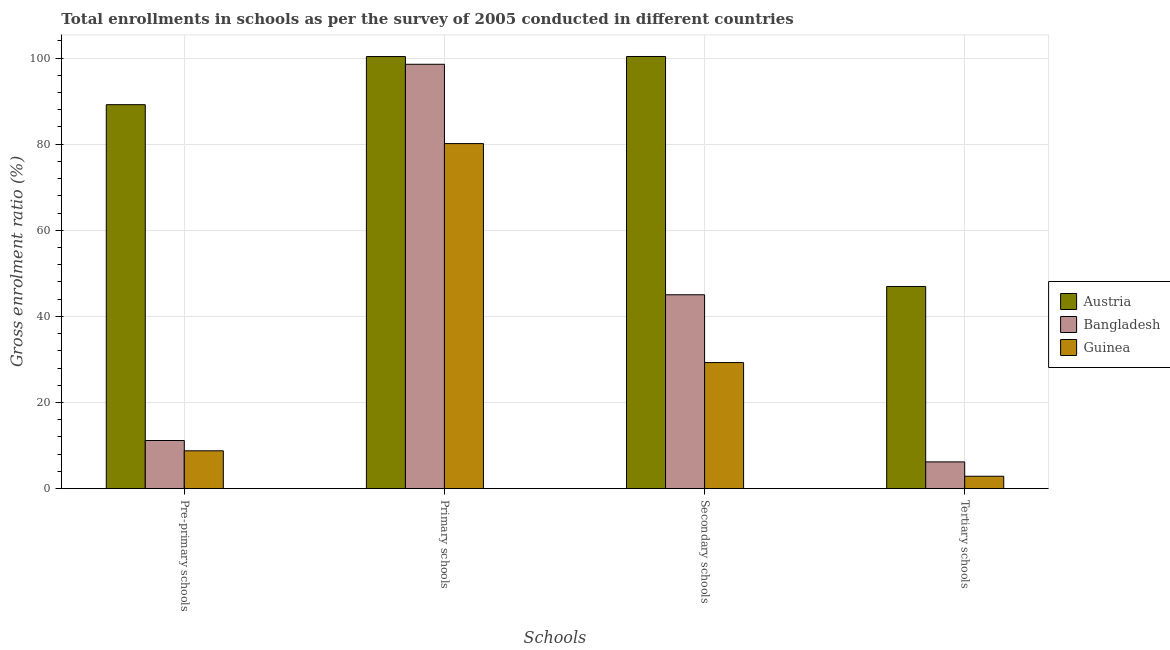Are the number of bars per tick equal to the number of legend labels?
Ensure brevity in your answer.  Yes. What is the label of the 3rd group of bars from the left?
Make the answer very short. Secondary schools. What is the gross enrolment ratio in tertiary schools in Bangladesh?
Give a very brief answer. 6.22. Across all countries, what is the maximum gross enrolment ratio in secondary schools?
Your answer should be very brief. 100.35. Across all countries, what is the minimum gross enrolment ratio in pre-primary schools?
Your answer should be compact. 8.79. In which country was the gross enrolment ratio in tertiary schools maximum?
Ensure brevity in your answer.  Austria. In which country was the gross enrolment ratio in primary schools minimum?
Offer a very short reply. Guinea. What is the total gross enrolment ratio in pre-primary schools in the graph?
Provide a short and direct response. 109.14. What is the difference between the gross enrolment ratio in secondary schools in Guinea and that in Austria?
Provide a succinct answer. -71.07. What is the difference between the gross enrolment ratio in primary schools in Bangladesh and the gross enrolment ratio in pre-primary schools in Austria?
Offer a terse response. 9.38. What is the average gross enrolment ratio in secondary schools per country?
Give a very brief answer. 58.22. What is the difference between the gross enrolment ratio in pre-primary schools and gross enrolment ratio in secondary schools in Guinea?
Keep it short and to the point. -20.49. What is the ratio of the gross enrolment ratio in primary schools in Austria to that in Guinea?
Offer a very short reply. 1.25. What is the difference between the highest and the second highest gross enrolment ratio in tertiary schools?
Keep it short and to the point. 40.73. What is the difference between the highest and the lowest gross enrolment ratio in secondary schools?
Provide a succinct answer. 71.07. What does the 3rd bar from the left in Primary schools represents?
Provide a short and direct response. Guinea. What does the 1st bar from the right in Tertiary schools represents?
Your answer should be very brief. Guinea. How many bars are there?
Ensure brevity in your answer.  12. How many countries are there in the graph?
Keep it short and to the point. 3. What is the difference between two consecutive major ticks on the Y-axis?
Give a very brief answer. 20. Are the values on the major ticks of Y-axis written in scientific E-notation?
Keep it short and to the point. No. Does the graph contain any zero values?
Provide a short and direct response. No. How many legend labels are there?
Ensure brevity in your answer.  3. How are the legend labels stacked?
Offer a terse response. Vertical. What is the title of the graph?
Make the answer very short. Total enrollments in schools as per the survey of 2005 conducted in different countries. What is the label or title of the X-axis?
Provide a succinct answer. Schools. What is the label or title of the Y-axis?
Provide a short and direct response. Gross enrolment ratio (%). What is the Gross enrolment ratio (%) of Austria in Pre-primary schools?
Your answer should be very brief. 89.16. What is the Gross enrolment ratio (%) in Bangladesh in Pre-primary schools?
Provide a succinct answer. 11.18. What is the Gross enrolment ratio (%) of Guinea in Pre-primary schools?
Your answer should be compact. 8.79. What is the Gross enrolment ratio (%) of Austria in Primary schools?
Keep it short and to the point. 100.33. What is the Gross enrolment ratio (%) in Bangladesh in Primary schools?
Offer a very short reply. 98.54. What is the Gross enrolment ratio (%) of Guinea in Primary schools?
Provide a short and direct response. 80.13. What is the Gross enrolment ratio (%) of Austria in Secondary schools?
Provide a short and direct response. 100.35. What is the Gross enrolment ratio (%) in Bangladesh in Secondary schools?
Provide a short and direct response. 45.02. What is the Gross enrolment ratio (%) of Guinea in Secondary schools?
Your response must be concise. 29.28. What is the Gross enrolment ratio (%) of Austria in Tertiary schools?
Keep it short and to the point. 46.95. What is the Gross enrolment ratio (%) of Bangladesh in Tertiary schools?
Provide a short and direct response. 6.22. What is the Gross enrolment ratio (%) in Guinea in Tertiary schools?
Make the answer very short. 2.89. Across all Schools, what is the maximum Gross enrolment ratio (%) in Austria?
Keep it short and to the point. 100.35. Across all Schools, what is the maximum Gross enrolment ratio (%) in Bangladesh?
Your response must be concise. 98.54. Across all Schools, what is the maximum Gross enrolment ratio (%) in Guinea?
Make the answer very short. 80.13. Across all Schools, what is the minimum Gross enrolment ratio (%) of Austria?
Keep it short and to the point. 46.95. Across all Schools, what is the minimum Gross enrolment ratio (%) of Bangladesh?
Offer a terse response. 6.22. Across all Schools, what is the minimum Gross enrolment ratio (%) of Guinea?
Your response must be concise. 2.89. What is the total Gross enrolment ratio (%) of Austria in the graph?
Provide a succinct answer. 336.8. What is the total Gross enrolment ratio (%) of Bangladesh in the graph?
Your response must be concise. 160.97. What is the total Gross enrolment ratio (%) in Guinea in the graph?
Your response must be concise. 121.09. What is the difference between the Gross enrolment ratio (%) in Austria in Pre-primary schools and that in Primary schools?
Provide a succinct answer. -11.17. What is the difference between the Gross enrolment ratio (%) of Bangladesh in Pre-primary schools and that in Primary schools?
Make the answer very short. -87.36. What is the difference between the Gross enrolment ratio (%) of Guinea in Pre-primary schools and that in Primary schools?
Provide a succinct answer. -71.33. What is the difference between the Gross enrolment ratio (%) in Austria in Pre-primary schools and that in Secondary schools?
Offer a very short reply. -11.19. What is the difference between the Gross enrolment ratio (%) in Bangladesh in Pre-primary schools and that in Secondary schools?
Provide a short and direct response. -33.84. What is the difference between the Gross enrolment ratio (%) of Guinea in Pre-primary schools and that in Secondary schools?
Provide a succinct answer. -20.49. What is the difference between the Gross enrolment ratio (%) in Austria in Pre-primary schools and that in Tertiary schools?
Provide a succinct answer. 42.21. What is the difference between the Gross enrolment ratio (%) of Bangladesh in Pre-primary schools and that in Tertiary schools?
Ensure brevity in your answer.  4.96. What is the difference between the Gross enrolment ratio (%) of Guinea in Pre-primary schools and that in Tertiary schools?
Your answer should be very brief. 5.91. What is the difference between the Gross enrolment ratio (%) of Austria in Primary schools and that in Secondary schools?
Make the answer very short. -0.02. What is the difference between the Gross enrolment ratio (%) in Bangladesh in Primary schools and that in Secondary schools?
Your response must be concise. 53.52. What is the difference between the Gross enrolment ratio (%) in Guinea in Primary schools and that in Secondary schools?
Give a very brief answer. 50.85. What is the difference between the Gross enrolment ratio (%) of Austria in Primary schools and that in Tertiary schools?
Provide a succinct answer. 53.39. What is the difference between the Gross enrolment ratio (%) in Bangladesh in Primary schools and that in Tertiary schools?
Your answer should be very brief. 92.32. What is the difference between the Gross enrolment ratio (%) in Guinea in Primary schools and that in Tertiary schools?
Your answer should be compact. 77.24. What is the difference between the Gross enrolment ratio (%) of Austria in Secondary schools and that in Tertiary schools?
Offer a very short reply. 53.4. What is the difference between the Gross enrolment ratio (%) in Bangladesh in Secondary schools and that in Tertiary schools?
Your answer should be very brief. 38.8. What is the difference between the Gross enrolment ratio (%) of Guinea in Secondary schools and that in Tertiary schools?
Offer a very short reply. 26.4. What is the difference between the Gross enrolment ratio (%) in Austria in Pre-primary schools and the Gross enrolment ratio (%) in Bangladesh in Primary schools?
Offer a terse response. -9.38. What is the difference between the Gross enrolment ratio (%) of Austria in Pre-primary schools and the Gross enrolment ratio (%) of Guinea in Primary schools?
Offer a terse response. 9.03. What is the difference between the Gross enrolment ratio (%) in Bangladesh in Pre-primary schools and the Gross enrolment ratio (%) in Guinea in Primary schools?
Provide a short and direct response. -68.94. What is the difference between the Gross enrolment ratio (%) of Austria in Pre-primary schools and the Gross enrolment ratio (%) of Bangladesh in Secondary schools?
Ensure brevity in your answer.  44.14. What is the difference between the Gross enrolment ratio (%) of Austria in Pre-primary schools and the Gross enrolment ratio (%) of Guinea in Secondary schools?
Offer a very short reply. 59.88. What is the difference between the Gross enrolment ratio (%) in Bangladesh in Pre-primary schools and the Gross enrolment ratio (%) in Guinea in Secondary schools?
Give a very brief answer. -18.1. What is the difference between the Gross enrolment ratio (%) in Austria in Pre-primary schools and the Gross enrolment ratio (%) in Bangladesh in Tertiary schools?
Offer a terse response. 82.94. What is the difference between the Gross enrolment ratio (%) of Austria in Pre-primary schools and the Gross enrolment ratio (%) of Guinea in Tertiary schools?
Your response must be concise. 86.28. What is the difference between the Gross enrolment ratio (%) in Bangladesh in Pre-primary schools and the Gross enrolment ratio (%) in Guinea in Tertiary schools?
Your response must be concise. 8.3. What is the difference between the Gross enrolment ratio (%) in Austria in Primary schools and the Gross enrolment ratio (%) in Bangladesh in Secondary schools?
Your answer should be very brief. 55.31. What is the difference between the Gross enrolment ratio (%) of Austria in Primary schools and the Gross enrolment ratio (%) of Guinea in Secondary schools?
Offer a terse response. 71.05. What is the difference between the Gross enrolment ratio (%) in Bangladesh in Primary schools and the Gross enrolment ratio (%) in Guinea in Secondary schools?
Ensure brevity in your answer.  69.26. What is the difference between the Gross enrolment ratio (%) of Austria in Primary schools and the Gross enrolment ratio (%) of Bangladesh in Tertiary schools?
Offer a terse response. 94.11. What is the difference between the Gross enrolment ratio (%) in Austria in Primary schools and the Gross enrolment ratio (%) in Guinea in Tertiary schools?
Provide a short and direct response. 97.45. What is the difference between the Gross enrolment ratio (%) of Bangladesh in Primary schools and the Gross enrolment ratio (%) of Guinea in Tertiary schools?
Your answer should be compact. 95.66. What is the difference between the Gross enrolment ratio (%) in Austria in Secondary schools and the Gross enrolment ratio (%) in Bangladesh in Tertiary schools?
Offer a very short reply. 94.13. What is the difference between the Gross enrolment ratio (%) of Austria in Secondary schools and the Gross enrolment ratio (%) of Guinea in Tertiary schools?
Make the answer very short. 97.47. What is the difference between the Gross enrolment ratio (%) of Bangladesh in Secondary schools and the Gross enrolment ratio (%) of Guinea in Tertiary schools?
Provide a succinct answer. 42.14. What is the average Gross enrolment ratio (%) in Austria per Schools?
Your response must be concise. 84.2. What is the average Gross enrolment ratio (%) of Bangladesh per Schools?
Provide a short and direct response. 40.24. What is the average Gross enrolment ratio (%) of Guinea per Schools?
Keep it short and to the point. 30.27. What is the difference between the Gross enrolment ratio (%) in Austria and Gross enrolment ratio (%) in Bangladesh in Pre-primary schools?
Offer a very short reply. 77.98. What is the difference between the Gross enrolment ratio (%) of Austria and Gross enrolment ratio (%) of Guinea in Pre-primary schools?
Ensure brevity in your answer.  80.37. What is the difference between the Gross enrolment ratio (%) of Bangladesh and Gross enrolment ratio (%) of Guinea in Pre-primary schools?
Offer a very short reply. 2.39. What is the difference between the Gross enrolment ratio (%) of Austria and Gross enrolment ratio (%) of Bangladesh in Primary schools?
Your response must be concise. 1.79. What is the difference between the Gross enrolment ratio (%) of Austria and Gross enrolment ratio (%) of Guinea in Primary schools?
Your answer should be compact. 20.21. What is the difference between the Gross enrolment ratio (%) in Bangladesh and Gross enrolment ratio (%) in Guinea in Primary schools?
Make the answer very short. 18.41. What is the difference between the Gross enrolment ratio (%) in Austria and Gross enrolment ratio (%) in Bangladesh in Secondary schools?
Give a very brief answer. 55.33. What is the difference between the Gross enrolment ratio (%) in Austria and Gross enrolment ratio (%) in Guinea in Secondary schools?
Give a very brief answer. 71.07. What is the difference between the Gross enrolment ratio (%) of Bangladesh and Gross enrolment ratio (%) of Guinea in Secondary schools?
Provide a succinct answer. 15.74. What is the difference between the Gross enrolment ratio (%) in Austria and Gross enrolment ratio (%) in Bangladesh in Tertiary schools?
Offer a terse response. 40.73. What is the difference between the Gross enrolment ratio (%) in Austria and Gross enrolment ratio (%) in Guinea in Tertiary schools?
Ensure brevity in your answer.  44.06. What is the difference between the Gross enrolment ratio (%) of Bangladesh and Gross enrolment ratio (%) of Guinea in Tertiary schools?
Ensure brevity in your answer.  3.33. What is the ratio of the Gross enrolment ratio (%) in Austria in Pre-primary schools to that in Primary schools?
Offer a very short reply. 0.89. What is the ratio of the Gross enrolment ratio (%) of Bangladesh in Pre-primary schools to that in Primary schools?
Offer a very short reply. 0.11. What is the ratio of the Gross enrolment ratio (%) in Guinea in Pre-primary schools to that in Primary schools?
Make the answer very short. 0.11. What is the ratio of the Gross enrolment ratio (%) of Austria in Pre-primary schools to that in Secondary schools?
Ensure brevity in your answer.  0.89. What is the ratio of the Gross enrolment ratio (%) of Bangladesh in Pre-primary schools to that in Secondary schools?
Provide a succinct answer. 0.25. What is the ratio of the Gross enrolment ratio (%) in Guinea in Pre-primary schools to that in Secondary schools?
Offer a terse response. 0.3. What is the ratio of the Gross enrolment ratio (%) of Austria in Pre-primary schools to that in Tertiary schools?
Provide a succinct answer. 1.9. What is the ratio of the Gross enrolment ratio (%) in Bangladesh in Pre-primary schools to that in Tertiary schools?
Offer a terse response. 1.8. What is the ratio of the Gross enrolment ratio (%) of Guinea in Pre-primary schools to that in Tertiary schools?
Make the answer very short. 3.05. What is the ratio of the Gross enrolment ratio (%) of Bangladesh in Primary schools to that in Secondary schools?
Your response must be concise. 2.19. What is the ratio of the Gross enrolment ratio (%) in Guinea in Primary schools to that in Secondary schools?
Keep it short and to the point. 2.74. What is the ratio of the Gross enrolment ratio (%) of Austria in Primary schools to that in Tertiary schools?
Your response must be concise. 2.14. What is the ratio of the Gross enrolment ratio (%) in Bangladesh in Primary schools to that in Tertiary schools?
Your answer should be very brief. 15.84. What is the ratio of the Gross enrolment ratio (%) in Guinea in Primary schools to that in Tertiary schools?
Make the answer very short. 27.77. What is the ratio of the Gross enrolment ratio (%) in Austria in Secondary schools to that in Tertiary schools?
Offer a terse response. 2.14. What is the ratio of the Gross enrolment ratio (%) of Bangladesh in Secondary schools to that in Tertiary schools?
Ensure brevity in your answer.  7.24. What is the ratio of the Gross enrolment ratio (%) of Guinea in Secondary schools to that in Tertiary schools?
Keep it short and to the point. 10.15. What is the difference between the highest and the second highest Gross enrolment ratio (%) in Austria?
Offer a very short reply. 0.02. What is the difference between the highest and the second highest Gross enrolment ratio (%) of Bangladesh?
Give a very brief answer. 53.52. What is the difference between the highest and the second highest Gross enrolment ratio (%) in Guinea?
Your response must be concise. 50.85. What is the difference between the highest and the lowest Gross enrolment ratio (%) of Austria?
Give a very brief answer. 53.4. What is the difference between the highest and the lowest Gross enrolment ratio (%) of Bangladesh?
Your response must be concise. 92.32. What is the difference between the highest and the lowest Gross enrolment ratio (%) in Guinea?
Provide a succinct answer. 77.24. 